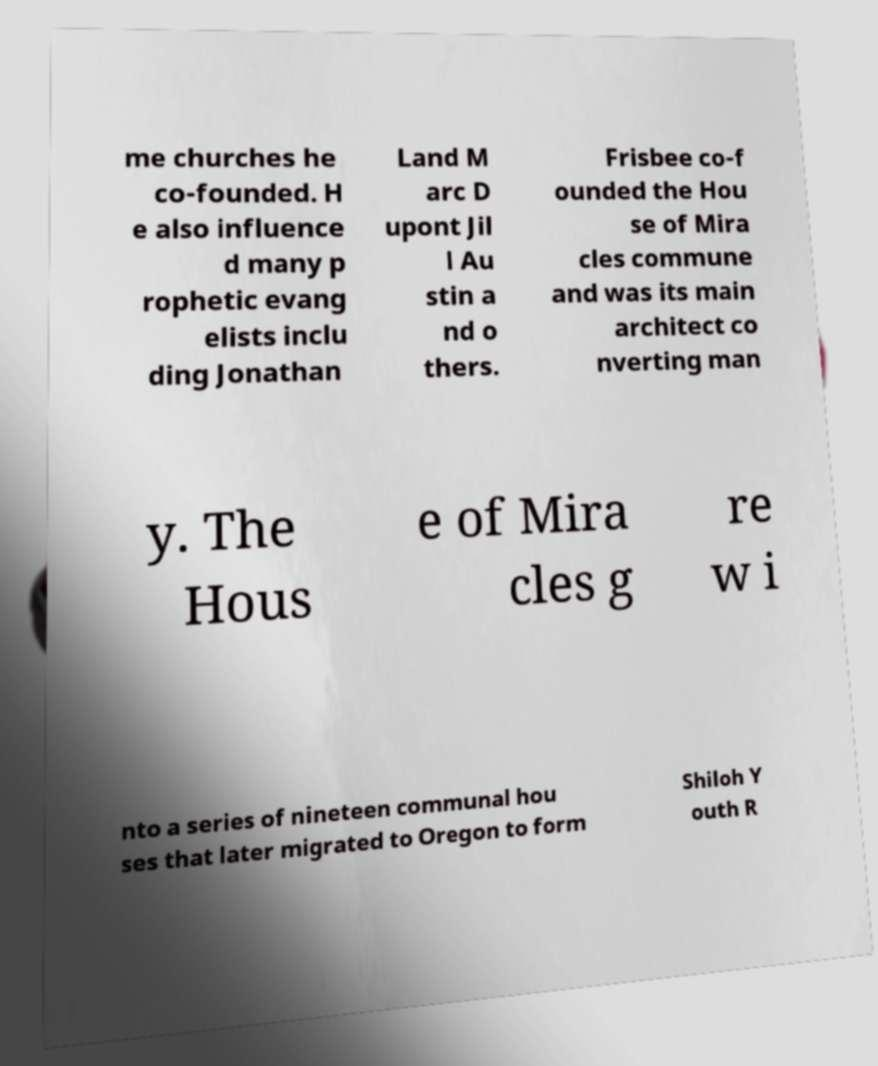For documentation purposes, I need the text within this image transcribed. Could you provide that? me churches he co-founded. H e also influence d many p rophetic evang elists inclu ding Jonathan Land M arc D upont Jil l Au stin a nd o thers. Frisbee co-f ounded the Hou se of Mira cles commune and was its main architect co nverting man y. The Hous e of Mira cles g re w i nto a series of nineteen communal hou ses that later migrated to Oregon to form Shiloh Y outh R 